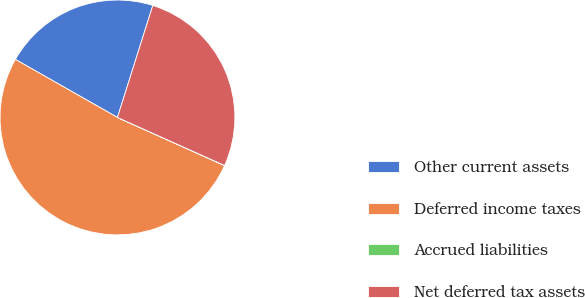Convert chart. <chart><loc_0><loc_0><loc_500><loc_500><pie_chart><fcel>Other current assets<fcel>Deferred income taxes<fcel>Accrued liabilities<fcel>Net deferred tax assets<nl><fcel>21.64%<fcel>51.5%<fcel>0.02%<fcel>26.84%<nl></chart> 